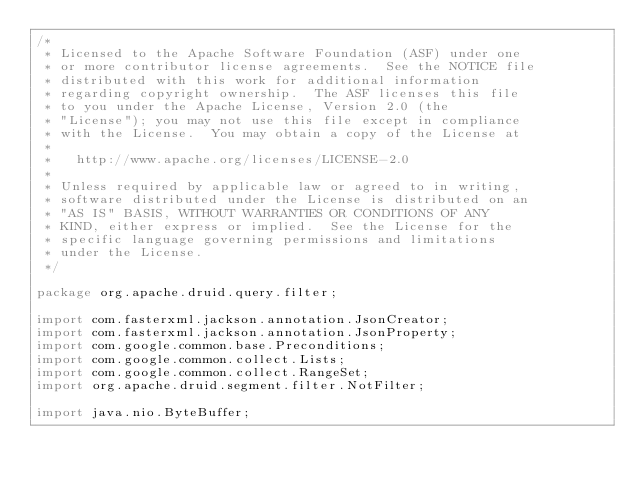Convert code to text. <code><loc_0><loc_0><loc_500><loc_500><_Java_>/*
 * Licensed to the Apache Software Foundation (ASF) under one
 * or more contributor license agreements.  See the NOTICE file
 * distributed with this work for additional information
 * regarding copyright ownership.  The ASF licenses this file
 * to you under the Apache License, Version 2.0 (the
 * "License"); you may not use this file except in compliance
 * with the License.  You may obtain a copy of the License at
 *
 *   http://www.apache.org/licenses/LICENSE-2.0
 *
 * Unless required by applicable law or agreed to in writing,
 * software distributed under the License is distributed on an
 * "AS IS" BASIS, WITHOUT WARRANTIES OR CONDITIONS OF ANY
 * KIND, either express or implied.  See the License for the
 * specific language governing permissions and limitations
 * under the License.
 */

package org.apache.druid.query.filter;

import com.fasterxml.jackson.annotation.JsonCreator;
import com.fasterxml.jackson.annotation.JsonProperty;
import com.google.common.base.Preconditions;
import com.google.common.collect.Lists;
import com.google.common.collect.RangeSet;
import org.apache.druid.segment.filter.NotFilter;

import java.nio.ByteBuffer;</code> 